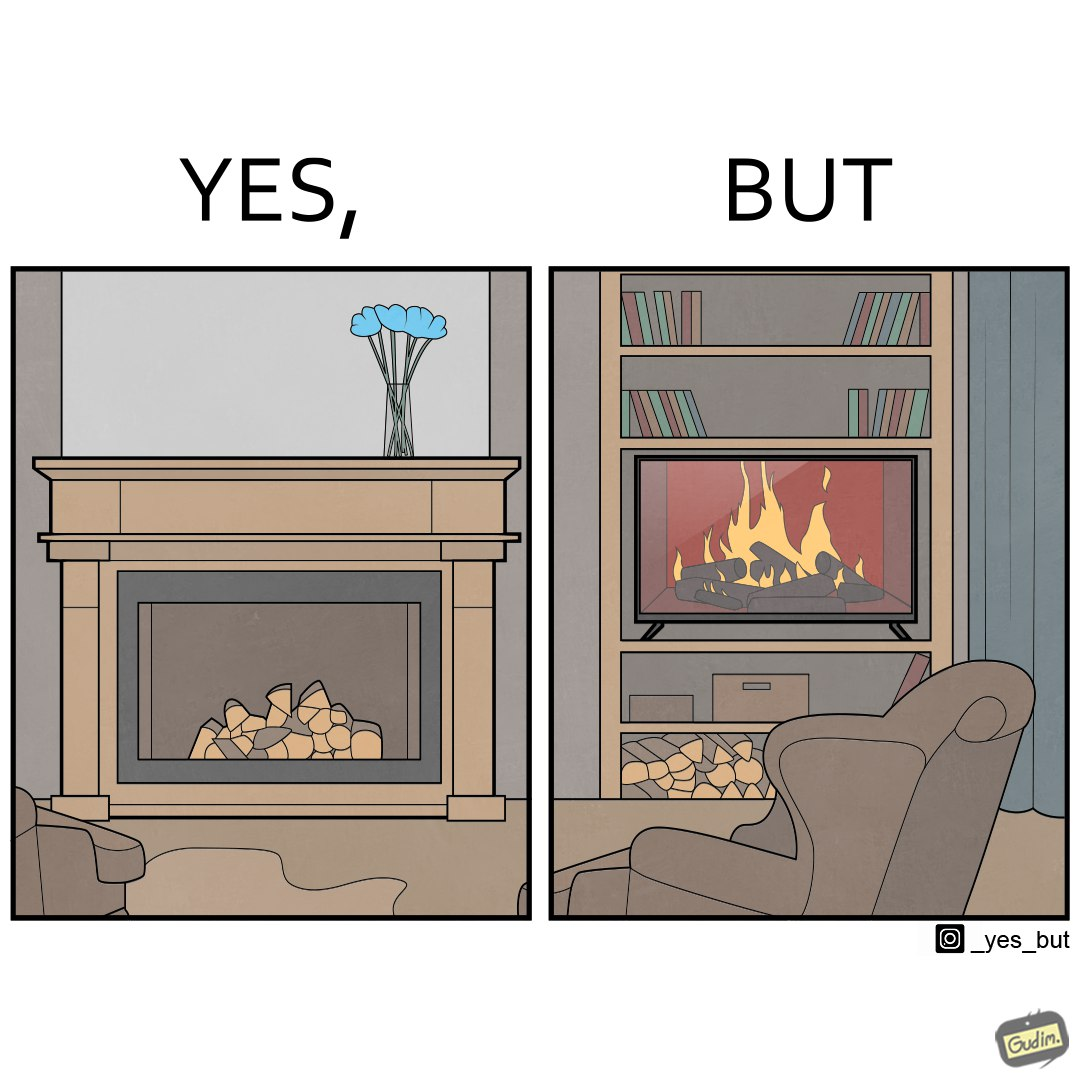What is shown in this image? The images are funny since they show how even though real fireplaces exist, people choose to be lazy and watch fireplaces on television because they dont want the inconveniences of cleaning up, etc. afterwards 